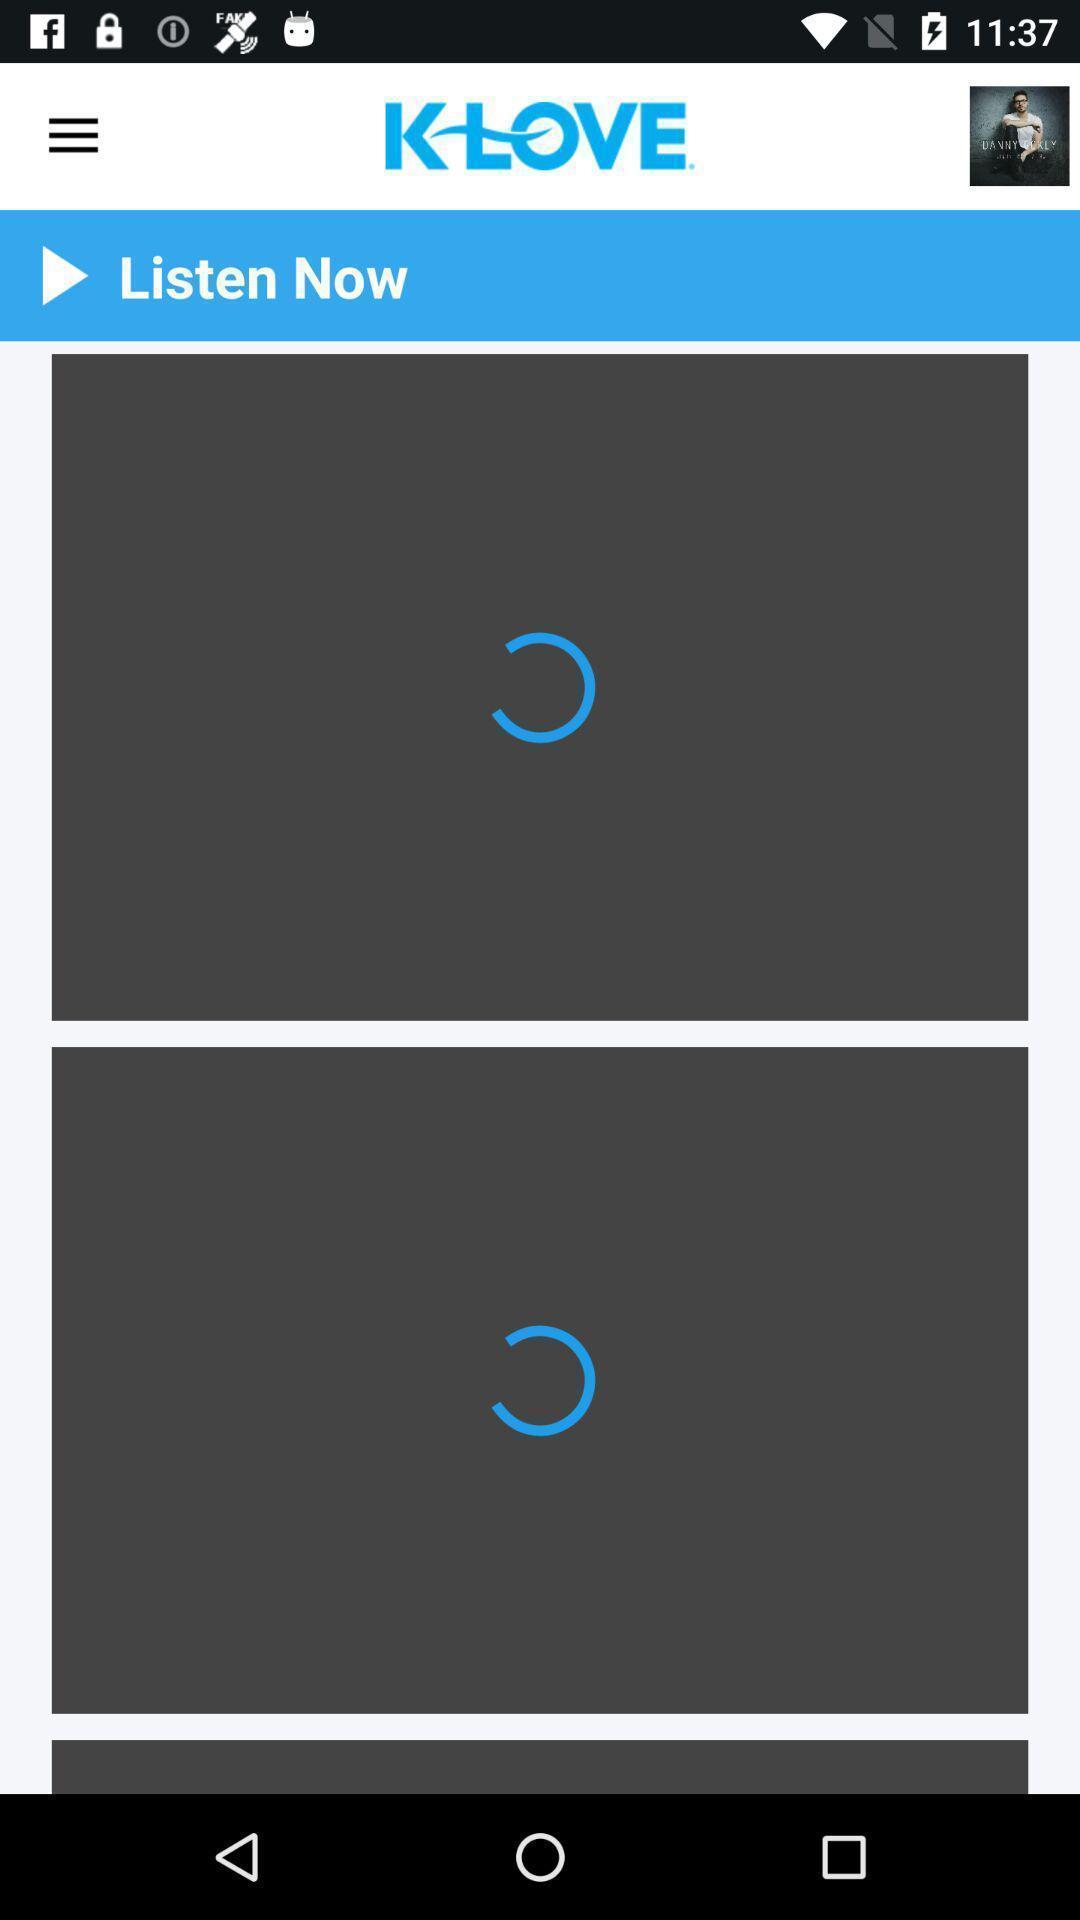What can you discern from this picture? Screen displaying the page of a music page. 